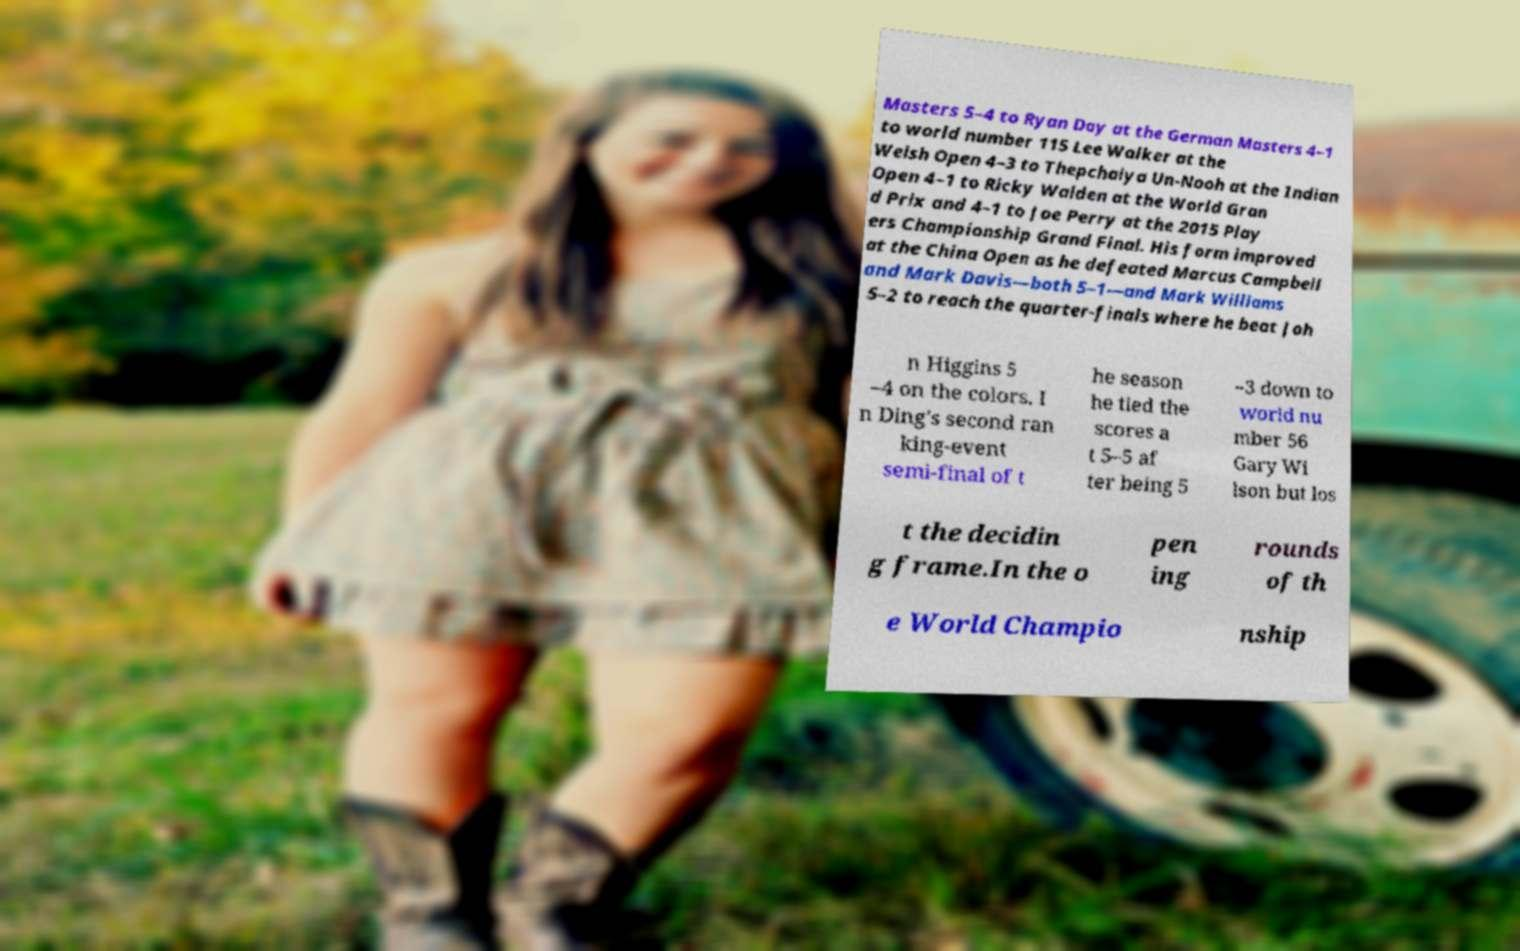Please read and relay the text visible in this image. What does it say? Masters 5–4 to Ryan Day at the German Masters 4–1 to world number 115 Lee Walker at the Welsh Open 4–3 to Thepchaiya Un-Nooh at the Indian Open 4–1 to Ricky Walden at the World Gran d Prix and 4–1 to Joe Perry at the 2015 Play ers Championship Grand Final. His form improved at the China Open as he defeated Marcus Campbell and Mark Davis—both 5–1—and Mark Williams 5–2 to reach the quarter-finals where he beat Joh n Higgins 5 –4 on the colors. I n Ding's second ran king-event semi-final of t he season he tied the scores a t 5–5 af ter being 5 –3 down to world nu mber 56 Gary Wi lson but los t the decidin g frame.In the o pen ing rounds of th e World Champio nship 